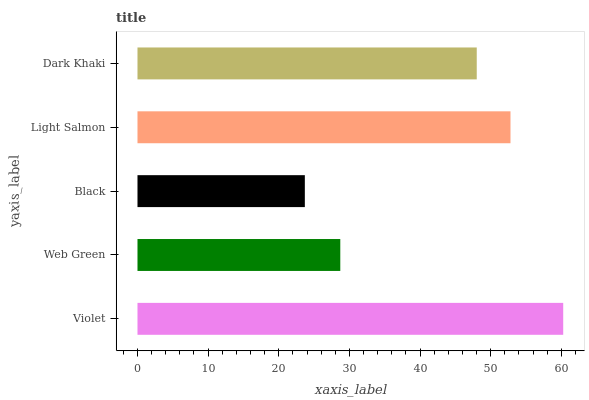Is Black the minimum?
Answer yes or no. Yes. Is Violet the maximum?
Answer yes or no. Yes. Is Web Green the minimum?
Answer yes or no. No. Is Web Green the maximum?
Answer yes or no. No. Is Violet greater than Web Green?
Answer yes or no. Yes. Is Web Green less than Violet?
Answer yes or no. Yes. Is Web Green greater than Violet?
Answer yes or no. No. Is Violet less than Web Green?
Answer yes or no. No. Is Dark Khaki the high median?
Answer yes or no. Yes. Is Dark Khaki the low median?
Answer yes or no. Yes. Is Violet the high median?
Answer yes or no. No. Is Black the low median?
Answer yes or no. No. 